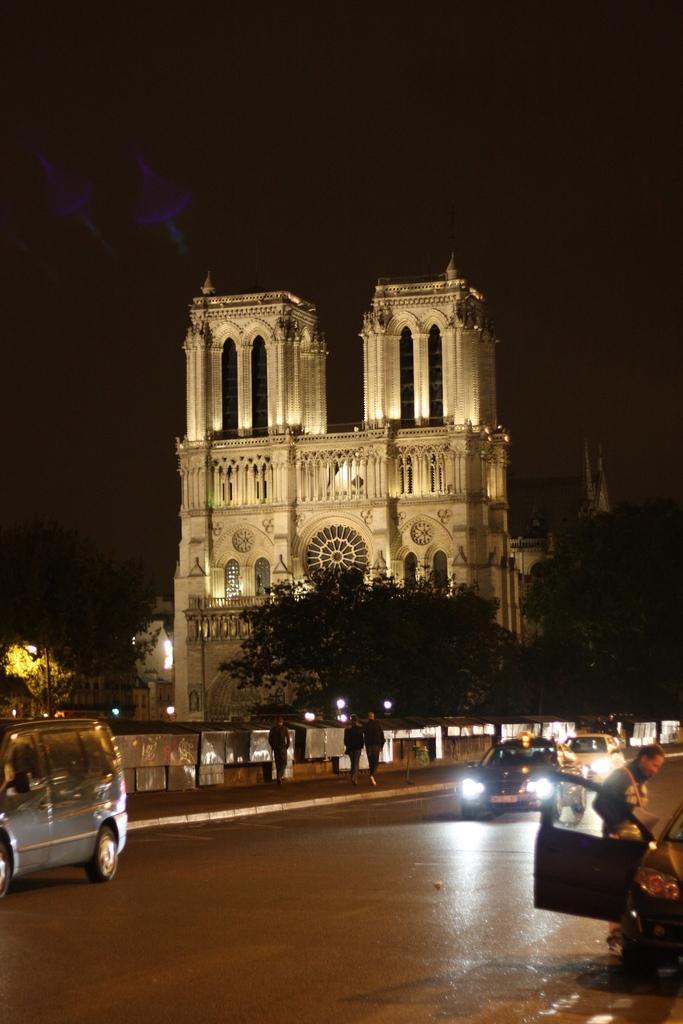Can you describe this image briefly? In this image there is a building beside that there are some trees and vehicles riding on the road, also there are people walking on the footpath. 